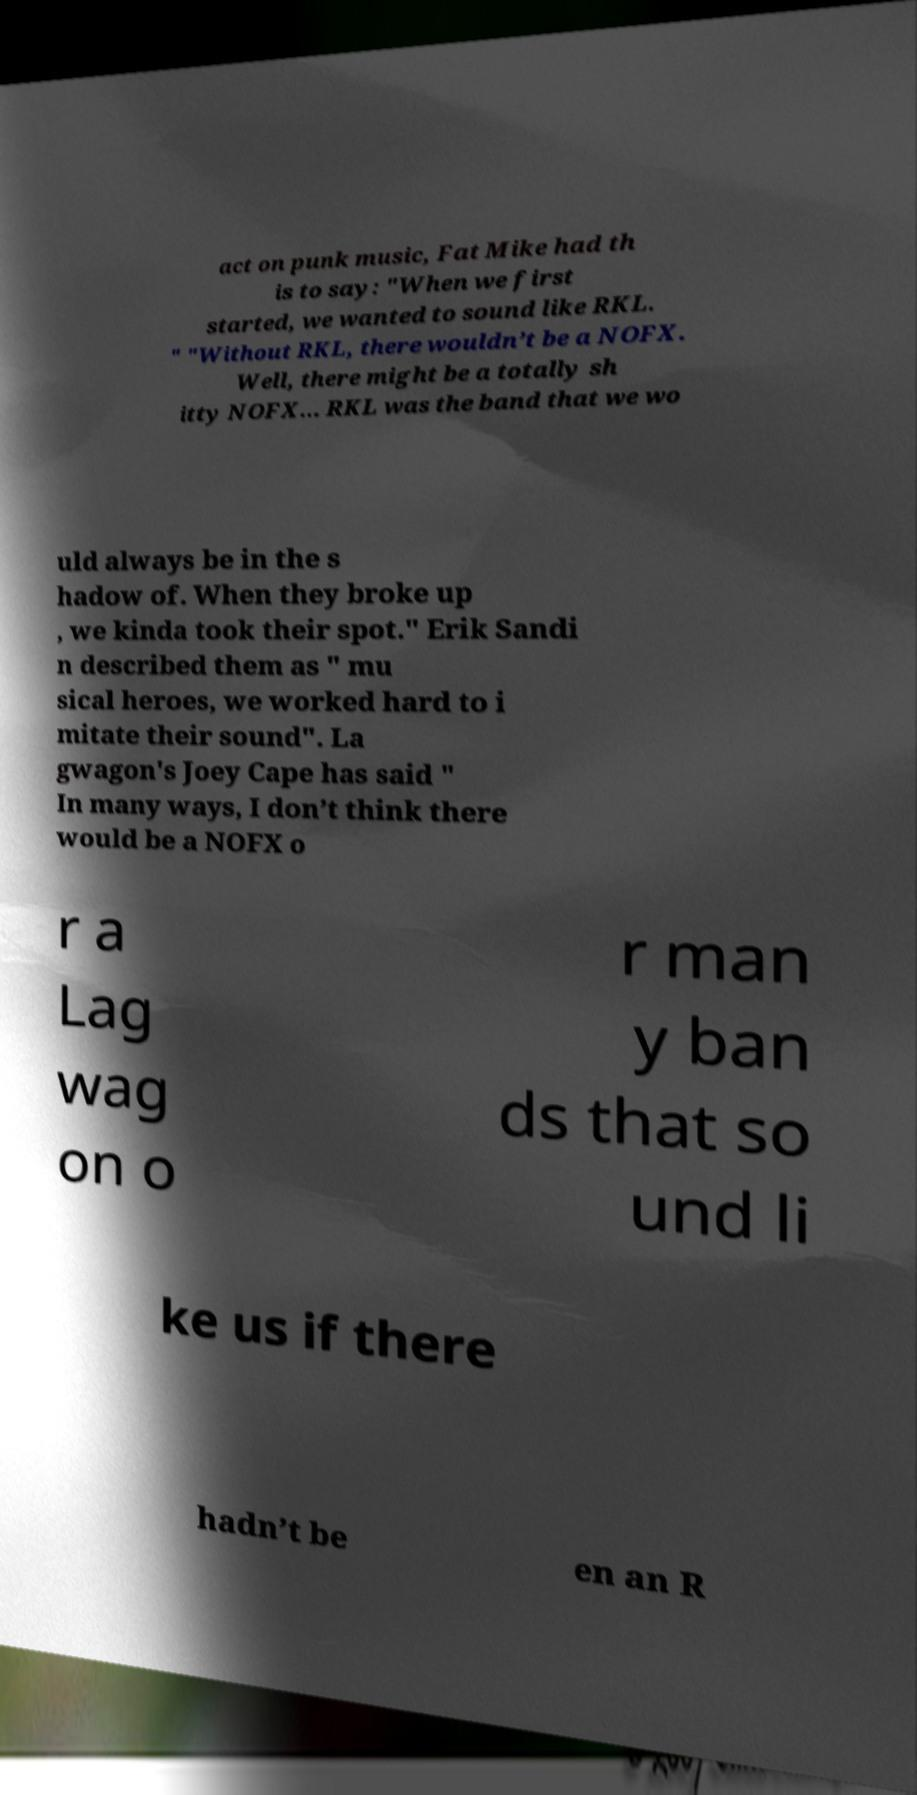There's text embedded in this image that I need extracted. Can you transcribe it verbatim? act on punk music, Fat Mike had th is to say: "When we first started, we wanted to sound like RKL. " "Without RKL, there wouldn’t be a NOFX. Well, there might be a totally sh itty NOFX... RKL was the band that we wo uld always be in the s hadow of. When they broke up , we kinda took their spot." Erik Sandi n described them as " mu sical heroes, we worked hard to i mitate their sound". La gwagon's Joey Cape has said " In many ways, I don’t think there would be a NOFX o r a Lag wag on o r man y ban ds that so und li ke us if there hadn’t be en an R 